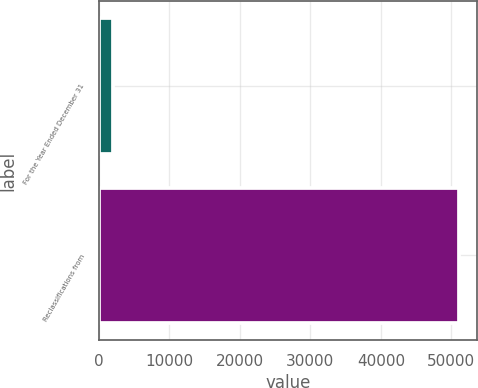Convert chart to OTSL. <chart><loc_0><loc_0><loc_500><loc_500><bar_chart><fcel>For the Year Ended December 31<fcel>Reclassifications from<nl><fcel>2017<fcel>51137<nl></chart> 